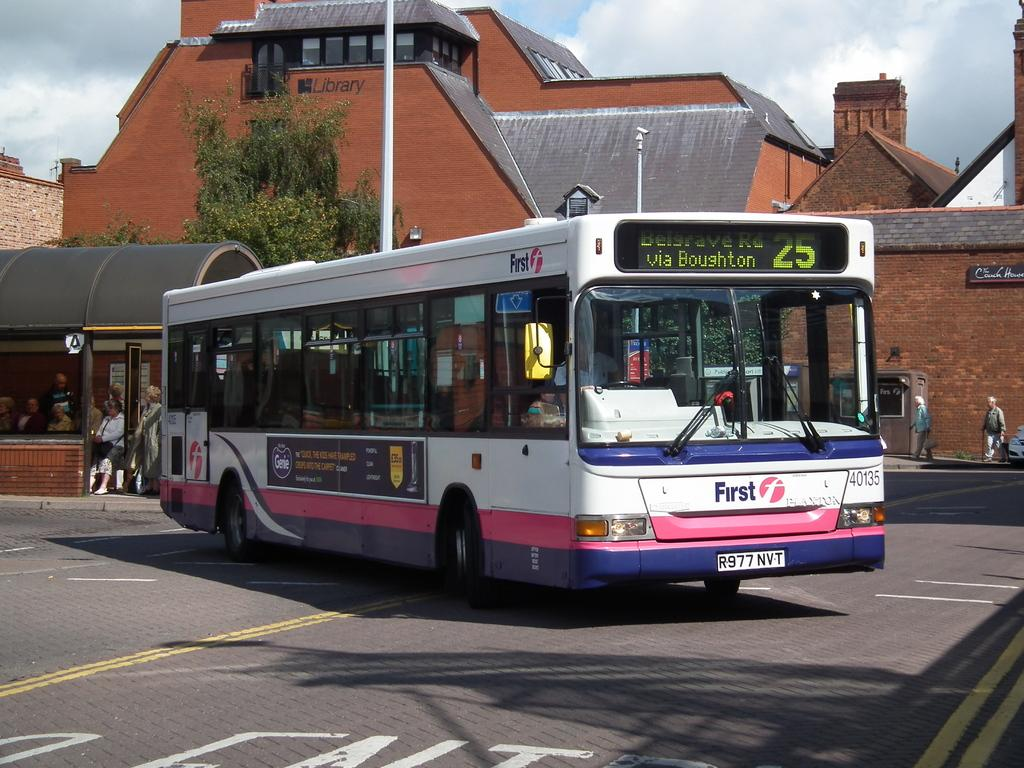<image>
Present a compact description of the photo's key features. A city bus pulls away from a bus stop with the displayed route information written across the top and the word FIRST written on the lower front. 